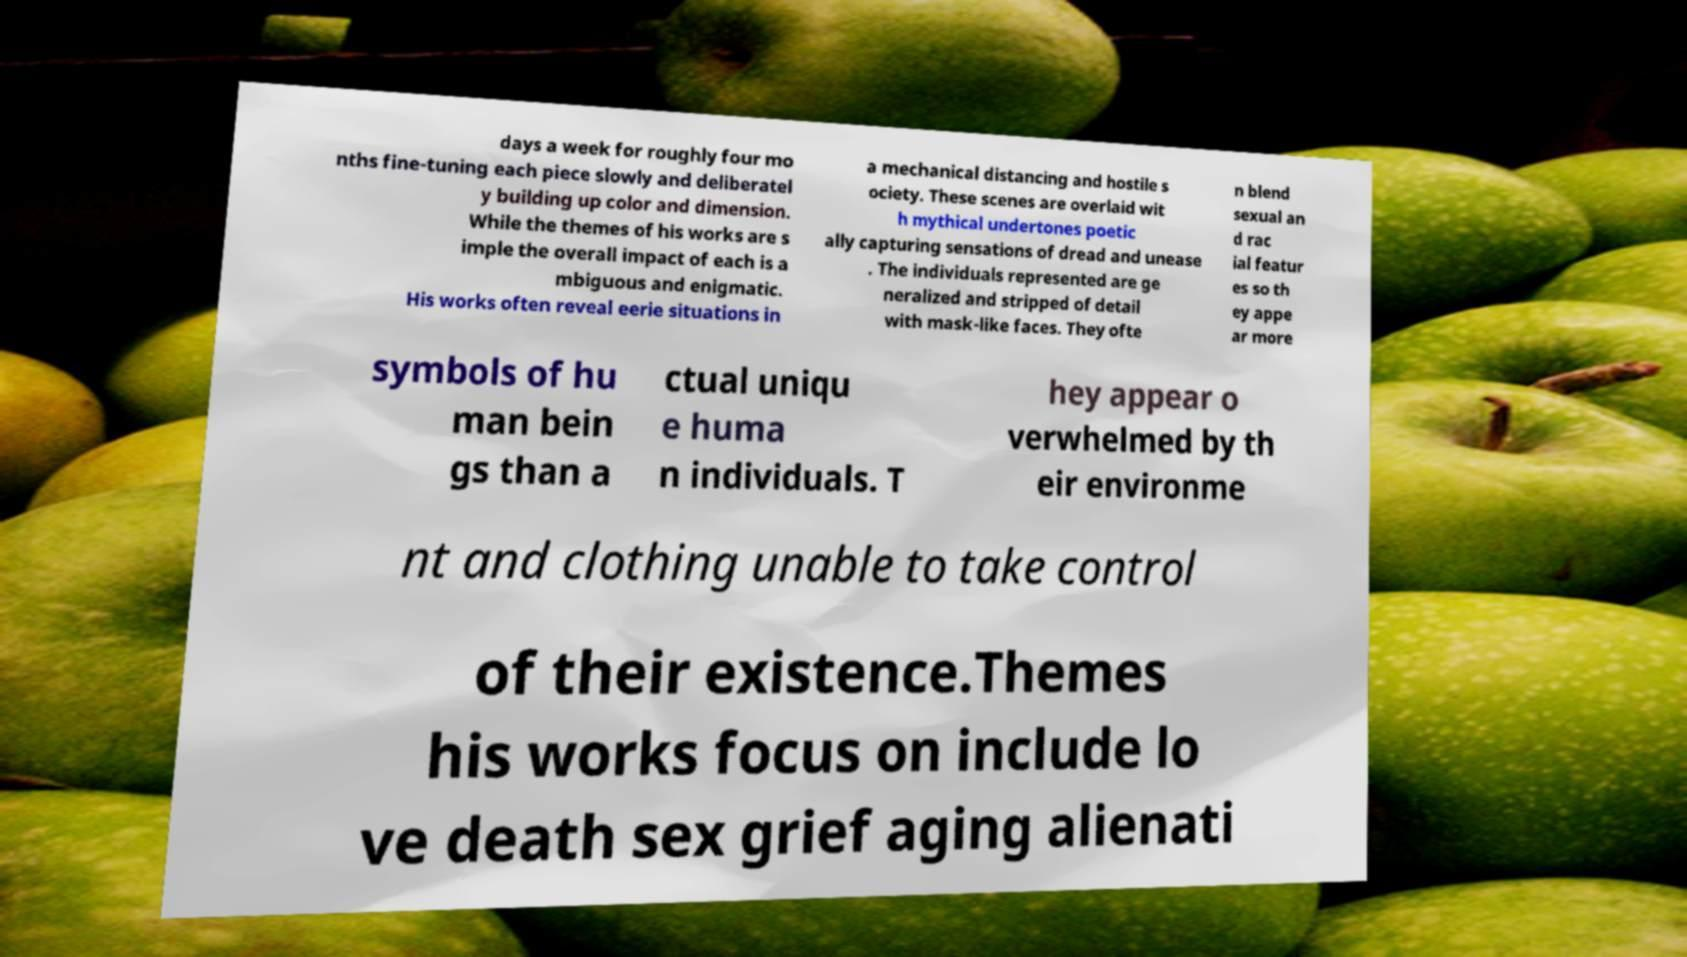What messages or text are displayed in this image? I need them in a readable, typed format. days a week for roughly four mo nths fine-tuning each piece slowly and deliberatel y building up color and dimension. While the themes of his works are s imple the overall impact of each is a mbiguous and enigmatic. His works often reveal eerie situations in a mechanical distancing and hostile s ociety. These scenes are overlaid wit h mythical undertones poetic ally capturing sensations of dread and unease . The individuals represented are ge neralized and stripped of detail with mask-like faces. They ofte n blend sexual an d rac ial featur es so th ey appe ar more symbols of hu man bein gs than a ctual uniqu e huma n individuals. T hey appear o verwhelmed by th eir environme nt and clothing unable to take control of their existence.Themes his works focus on include lo ve death sex grief aging alienati 